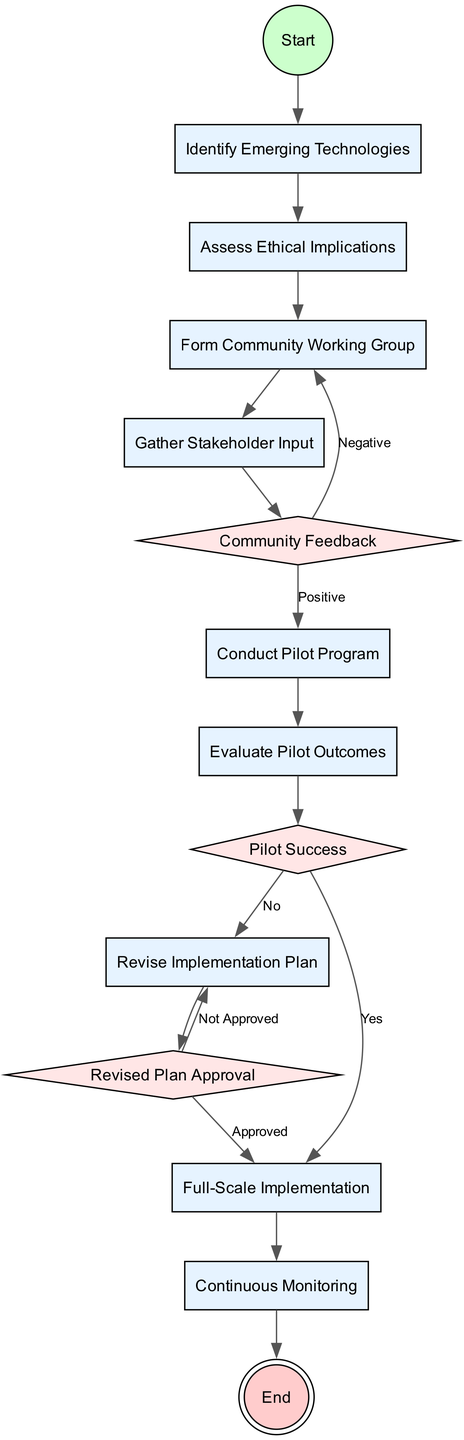What is the first activity in the diagram? The first activity is indicated after the "Start" node, which leads directly to "Identify Emerging Technologies."
Answer: Identify Emerging Technologies How many activities are there in total? By counting all the nodes of type "activity," we see there are eight activities listed in the diagram.
Answer: 8 What happens after the "Gather Stakeholder Input" activity? Following "Gather Stakeholder Input," the diagram proceeds to "Community Feedback," which represents a decision point.
Answer: Community Feedback What is the decision made after evaluating pilot outcomes? The decision after the "Evaluate Pilot Outcomes" node is represented by "Pilot Success," which will indicate if the pilot was successful or not.
Answer: Pilot Success If the pilot program is successful, what is the next step? If the pilot is successful, as indicated by a "Yes" label from "Pilot Success," the next step in the diagram is "Full-Scale Implementation."
Answer: Full-Scale Implementation What action is taken if the revised plan is not approved? If the revised plan is not approved, indicated by the label "Not Approved," the process loops back to "Revise Implementation Plan."
Answer: Revise Implementation Plan How do we acquire input from the community? Input from the community is gathered through the "Gather Stakeholder Input" activity, which follows the formation of the community working group.
Answer: Gather Stakeholder Input What node leads to continuous monitoring? After the "Full-Scale Implementation" node, the flow of the diagram clearly leads to "Continuous Monitoring," marking an ongoing evaluation phase.
Answer: Continuous Monitoring 